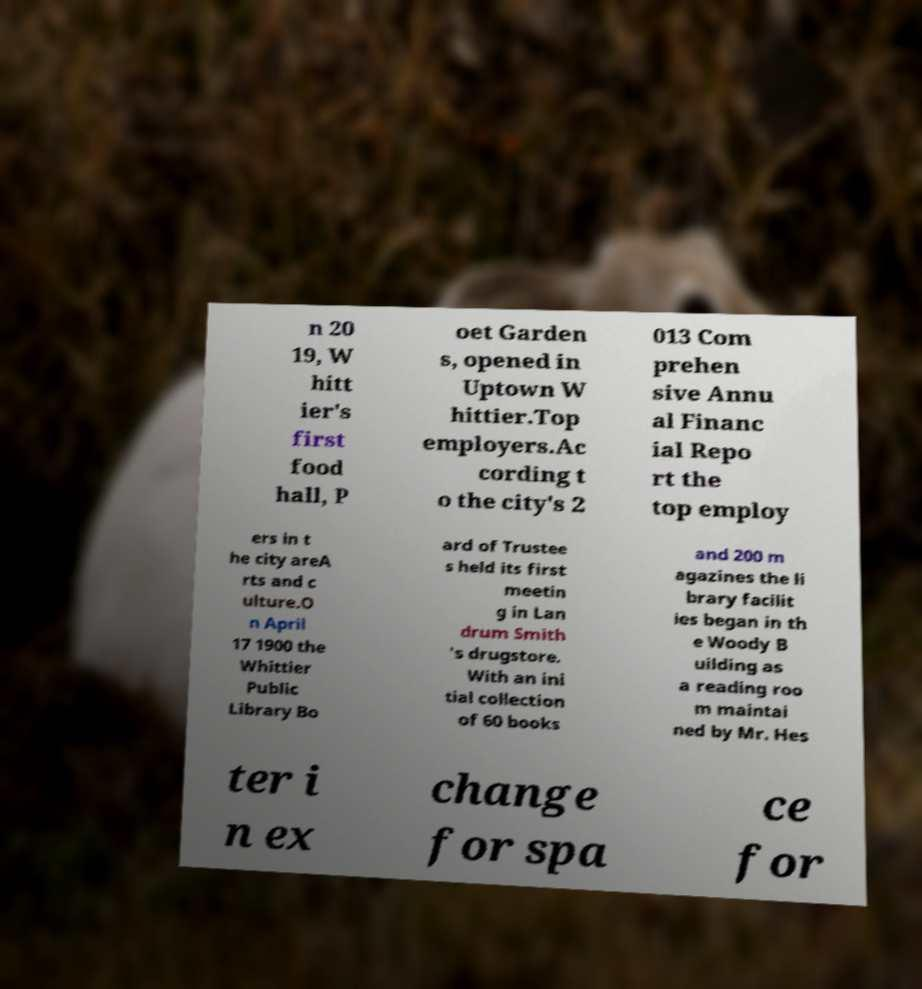I need the written content from this picture converted into text. Can you do that? n 20 19, W hitt ier's first food hall, P oet Garden s, opened in Uptown W hittier.Top employers.Ac cording t o the city's 2 013 Com prehen sive Annu al Financ ial Repo rt the top employ ers in t he city areA rts and c ulture.O n April 17 1900 the Whittier Public Library Bo ard of Trustee s held its first meetin g in Lan drum Smith 's drugstore. With an ini tial collection of 60 books and 200 m agazines the li brary facilit ies began in th e Woody B uilding as a reading roo m maintai ned by Mr. Hes ter i n ex change for spa ce for 